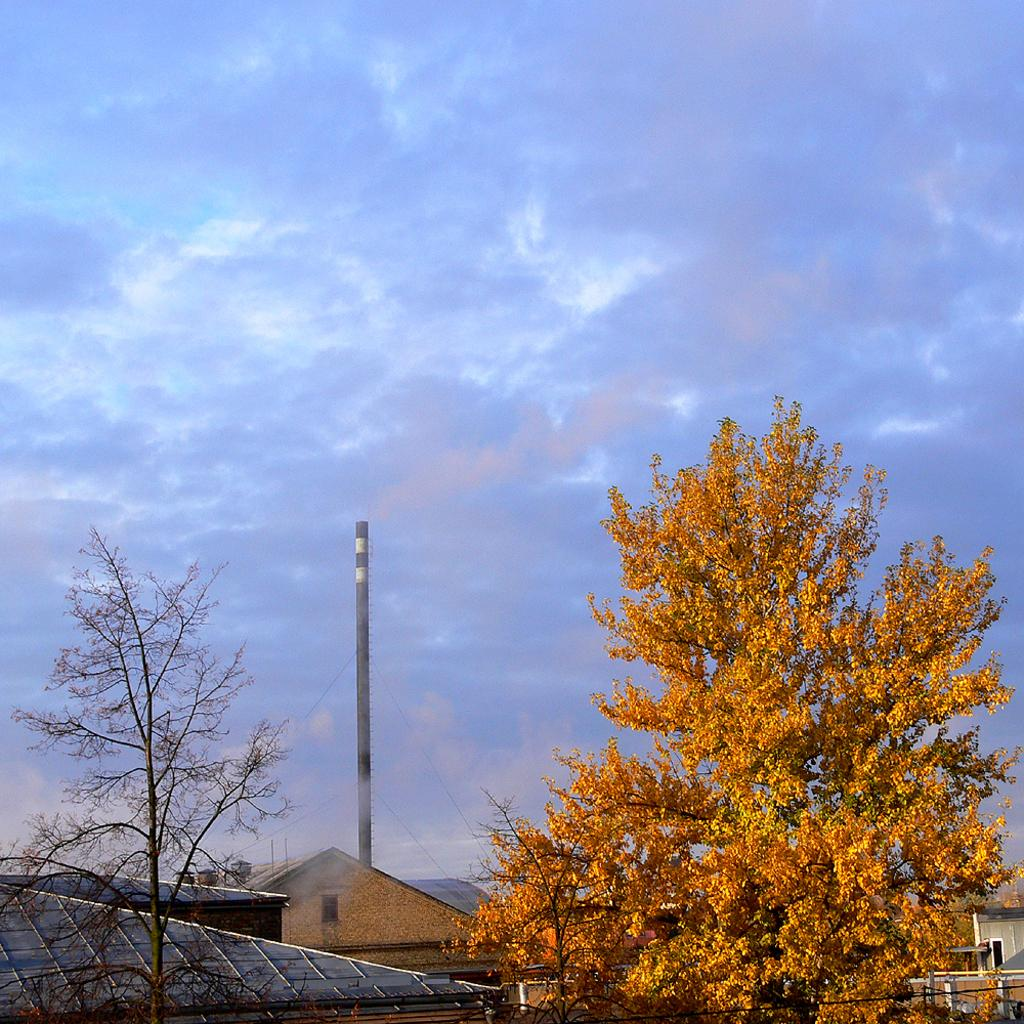What type of structure is visible in the image? There is a house in the image. What can be seen in the background of the image? There are trees and a pole in the background of the image. How would you describe the sky in the image? The sky is cloudy in the image. What type of brush is being used to paint the house in the image? There is no indication in the image that the house is being painted, nor is there a brush present. 